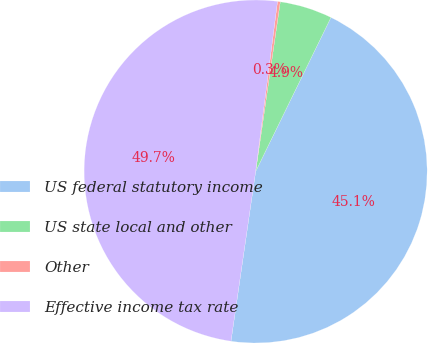<chart> <loc_0><loc_0><loc_500><loc_500><pie_chart><fcel>US federal statutory income<fcel>US state local and other<fcel>Other<fcel>Effective income tax rate<nl><fcel>45.06%<fcel>4.94%<fcel>0.26%<fcel>49.74%<nl></chart> 